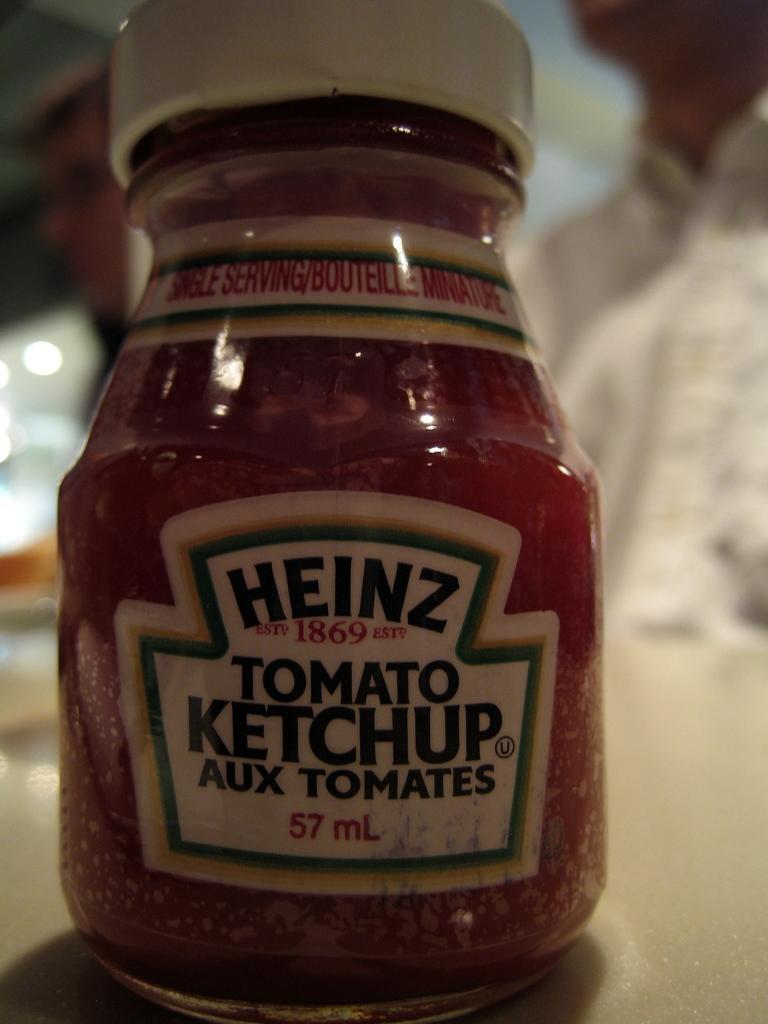Could you give a brief overview of what you see in this image? In this picture we can see one bottle is placed in a table and we can able to see a person at back side. 